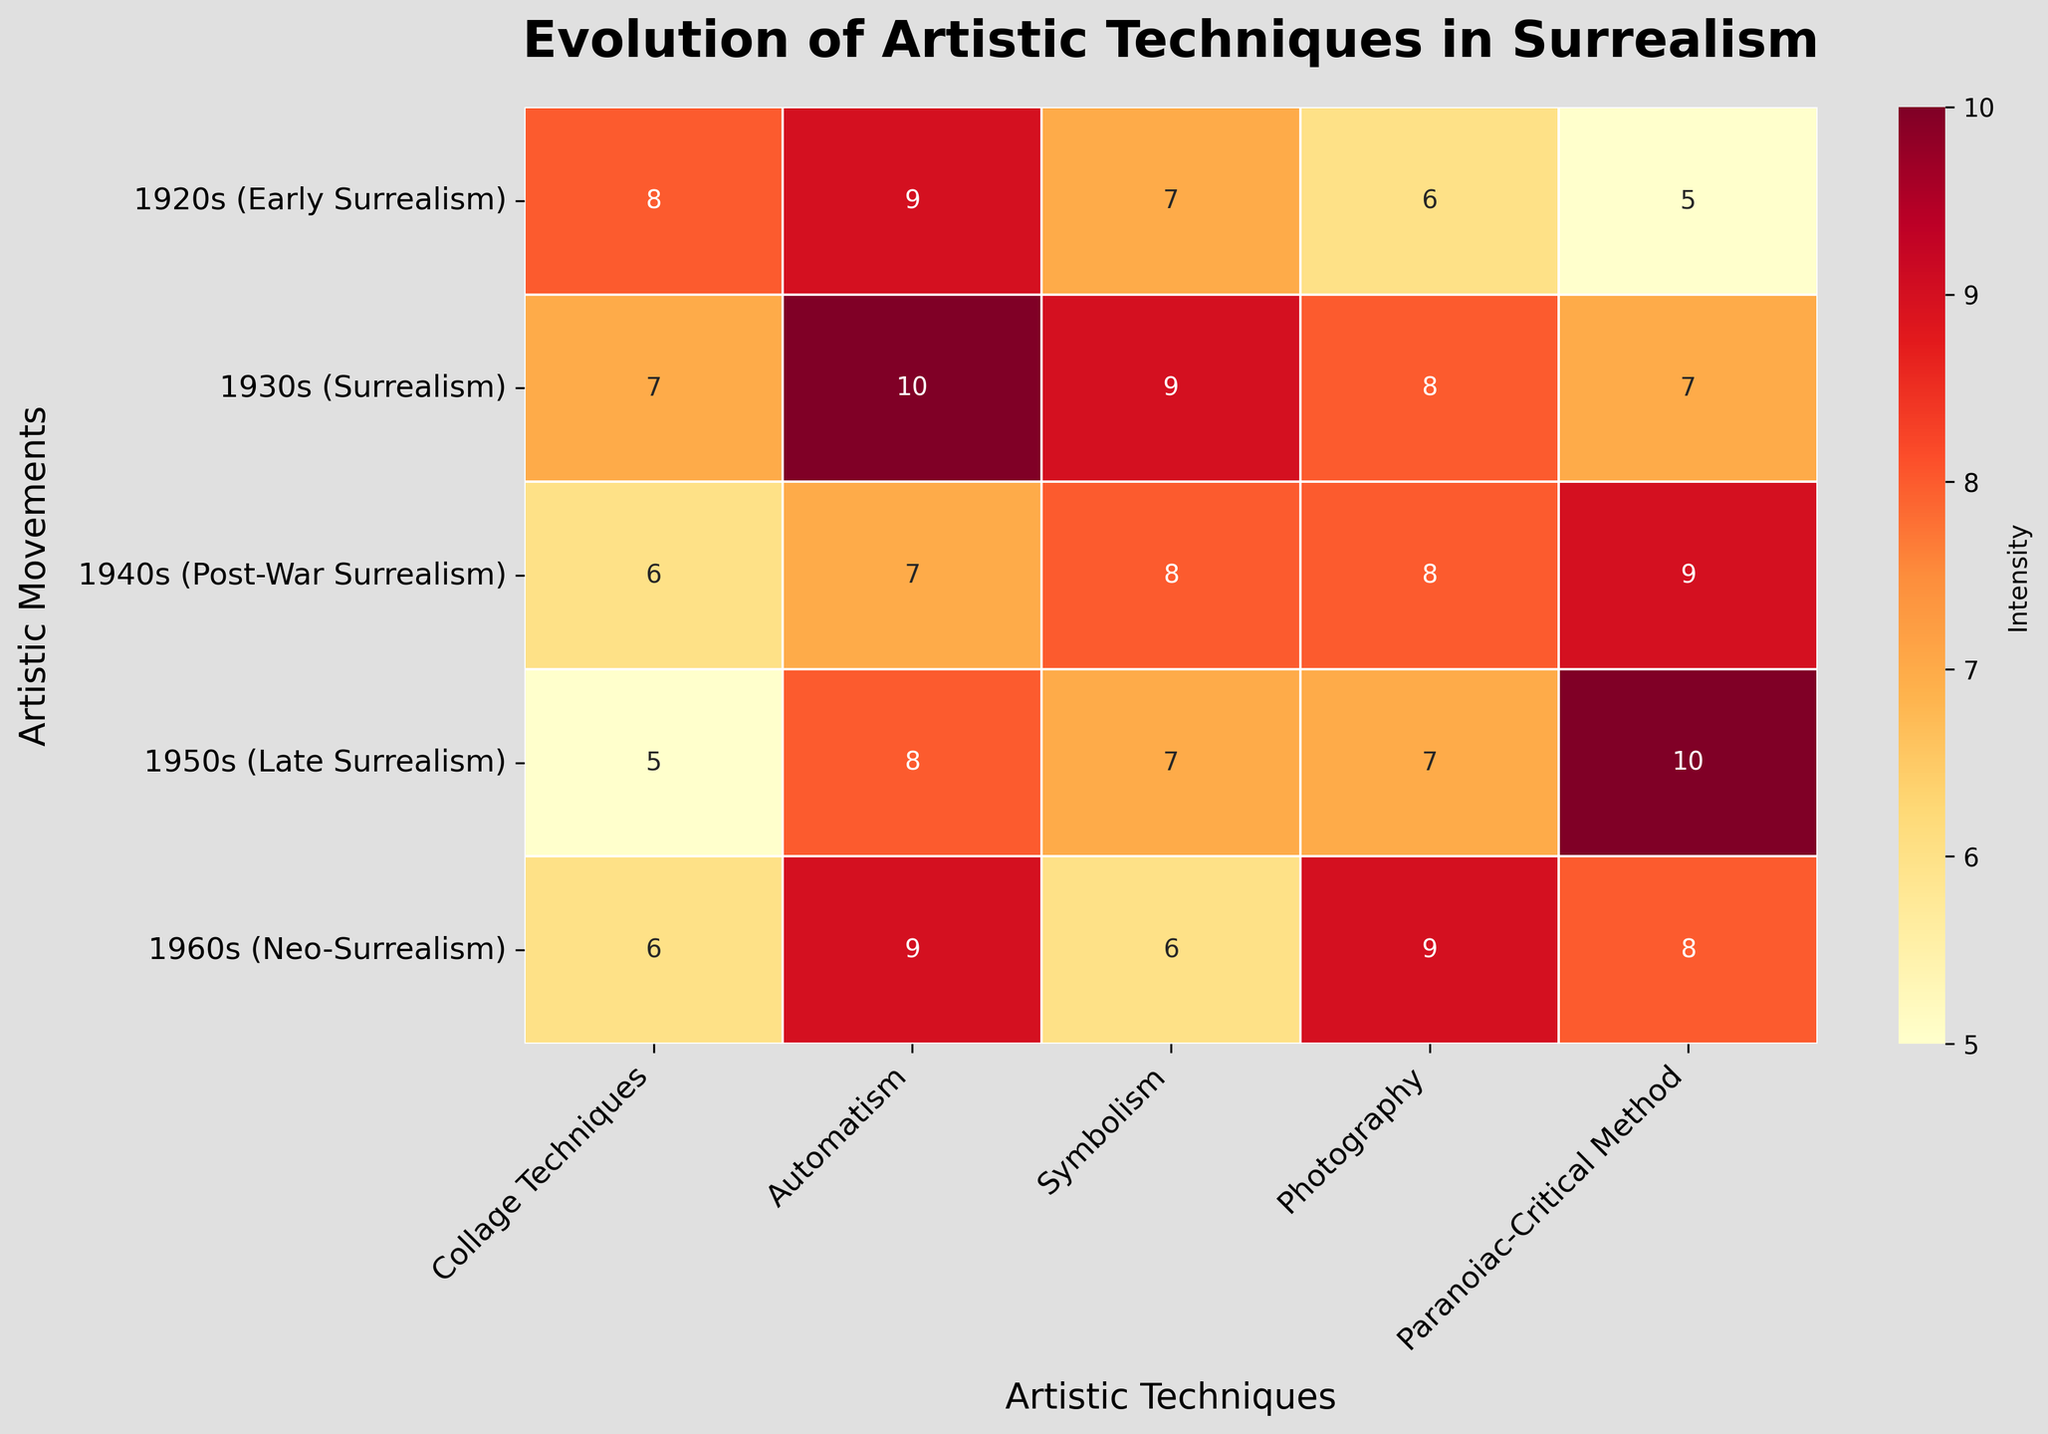What is the title of the heatmap? The title can be found at the top of the heatmap in larger and bolder font compared to other texts.
Answer: Evolution of Artistic Techniques in Surrealism Which artistic technique had the highest intensity in the 1950s (Late Surrealism)? Find the highest number in the row labeled "1950s (Late Surrealism)" and trace it to the column header. The values shown are 5, 8, 7, 7, 10, with 10 being the highest. The corresponding technique label is "Paranoiac-Critical Method."
Answer: Paranoiac-Critical Method How does "Automatism" change over the artistic movements? Look at the column labeled "Automatism" and observe the numerical values from top to bottom. They successively are 9, 10, 7, 8, 9. Describe the trend.
Answer: Generally fluctuating Which artistic movement has the lowest average intensity across all techniques? Calculate the average values for each row and compare them.
Answer: 1950s (Late Surrealism) What is the intensity difference of "Photography" between Early Surrealism (1920s) and Neo-Surrealism (1960s)? Identify the intensities in the "Photography" column for "1920s (Early Surrealism)" and "1960s (Neo-Surrealism)", which are 6 and 9 respectively. Subtract the earlier value from the later value.
Answer: 3 Which two artistic techniques are equal in intensity in the 1930s (Surrealism) and what is their value? Examine the second row labeled "1930s (Surrealism)" to find repeated values. "Photography" and "Automatism" both have a value of 8.
Answer: Photography and Automatism, 8 How many artistic techniques have a higher intensity in the 1940s (Post-War Surrealism) compared to the 1920s (Early Surrealism)? Compare the numerical values in each column between these two rows. Count how many times the 1940s value exceeds the 1920s value: Automatises (9 > 7), Symbolism (8 > 7), Photography (8 > 6), Paranoiac-Critical Method (9 > 5).
Answer: 4 What is the range of intensity values for "Symbolism" across all artistic movements? Identify the values for "Symbolism" which are 7, 9, 8, 7, 6. The range is the difference between the maximum and minimum values: 9 - 6 = 3.
Answer: 3 Which artistic movement used "Collage Techniques" least intensively and what was the value? Look for the minimum value in the "Collage Techniques" column. The values are 8, 7, 6, 5, 6, with 5 being the lowest, corresponding to the "1950s (Late Surrealism)" row.
Answer: 1950s (Late Surrealism), 5 